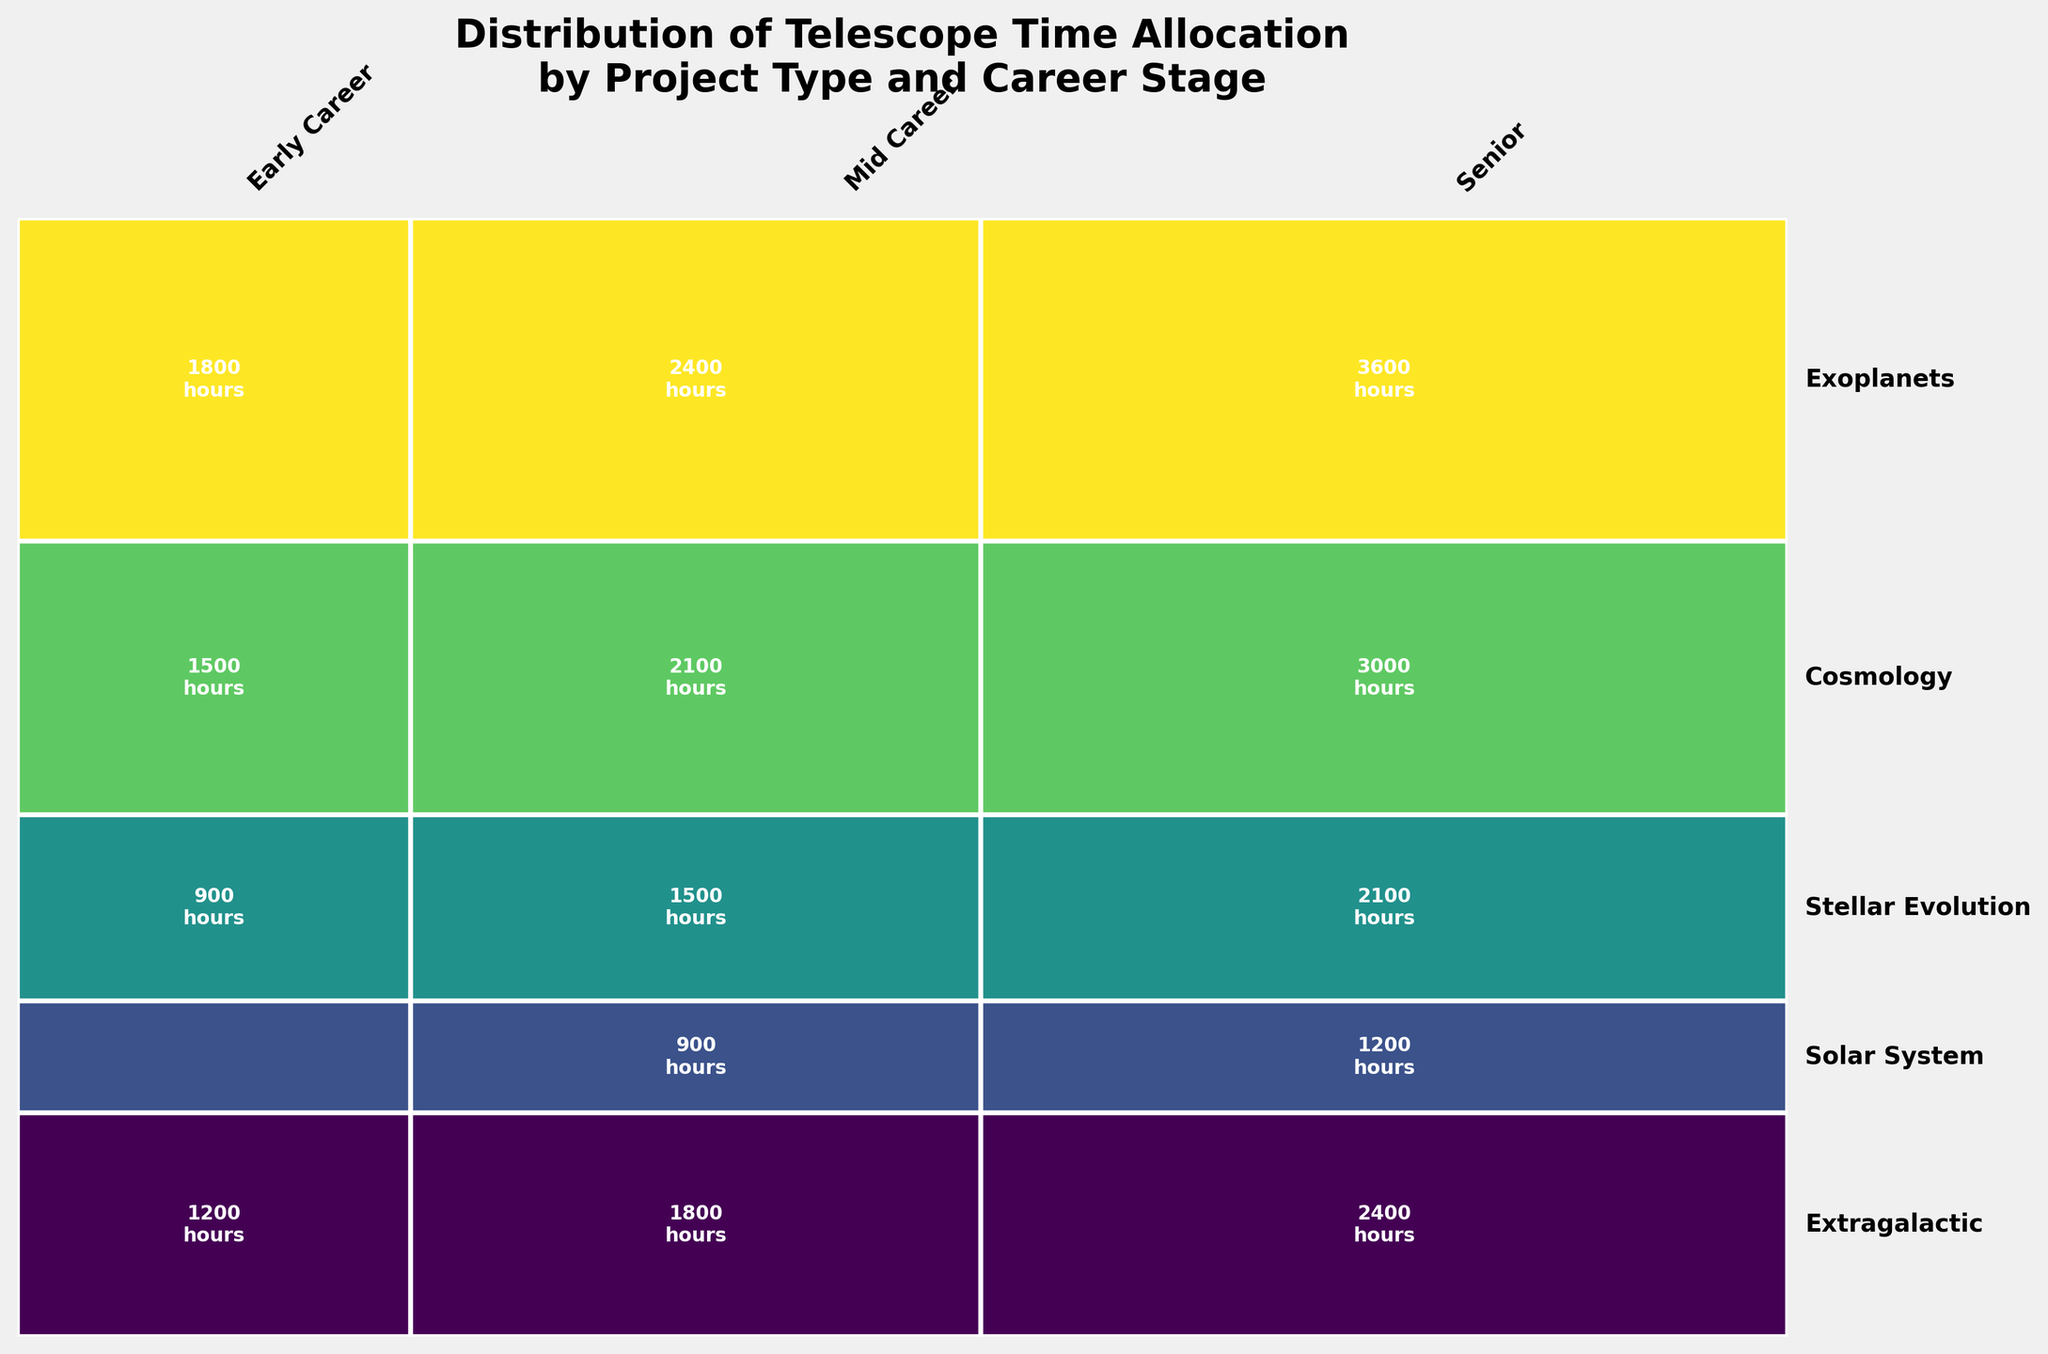Who receives the most telescope time allocation, early career researchers or senior researchers? To find out who receives the most telescope time, compare the total time allocation for all project types for both early career and senior researchers. By visually inspecting the figure, it is clear that the rectangles for senior researchers collectively cover a larger area than those for early career researchers, indicating they receive more time.
Answer: Senior researchers Which project type has the highest total telescope time allocation? Compare the vertical height of segments corresponding to each project type. The project type with the tallest combined rectangles has the highest total allocation. Cosmology has the largest vertical height indicating it has the highest allocation.
Answer: Cosmology Among senior researchers, which project type receives the least telescope time? Look at the horizontal segments corresponding to senior researchers across different project types and compare their widths. The width of the Solar System segment is the smallest among senior researchers, indicating it receives the least time.
Answer: Solar System What is the total telescope time allocation for mid-career researchers in the field of Exoplanets? Locate the rectangle segment for mid-career researchers within the Exoplanets project type and read the time allocation value displayed within. The figure shows a segment labeled 2400 hours for mid-career researchers in Exoplanets.
Answer: 2400 hours By how much does the telescope time allocation for senior researchers in Stellar Evolution exceed that of early career researchers in the same field? Find the time allocations for both senior (2100 hours) and early career (900 hours) researchers in Stellar Evolution by reading the values within the respective rectangles. Subtract the early career value from the senior value: 2100 hours - 900 hours.
Answer: 1200 hours Which researcher's career stage has the most balanced allocation across different project types? Inspect which career stage has fairly uniform widths of rectangles across different project types. Mid-career researchers have relatively balanced allocations, as the widths of their rectangles look almost equal for different projects.
Answer: Mid-career researchers What is the collective telescope time allocation for early career researchers? Sum the time allocations for all project types attributed to early career researchers: Extragalactic (1200) + Solar System (600) + Stellar Evolution (900) + Cosmology (1500) + Exoplanets (1800). Total is 6000 hours.
Answer: 6000 hours Which project type shows the largest disparity in time allocation between early and mid-career researchers? Compare the difference in rectangle widths for each project type corresponding to early and mid-career researchers. Exoplanets shows the largest difference, with 600 hours more allocated to mid-career researchers.
Answer: Exoplanets 